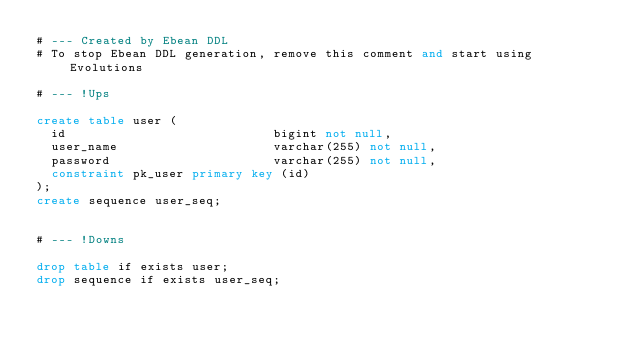<code> <loc_0><loc_0><loc_500><loc_500><_SQL_># --- Created by Ebean DDL
# To stop Ebean DDL generation, remove this comment and start using Evolutions

# --- !Ups

create table user (
  id                            bigint not null,
  user_name                     varchar(255) not null,
  password                      varchar(255) not null,
  constraint pk_user primary key (id)
);
create sequence user_seq;


# --- !Downs

drop table if exists user;
drop sequence if exists user_seq;

</code> 